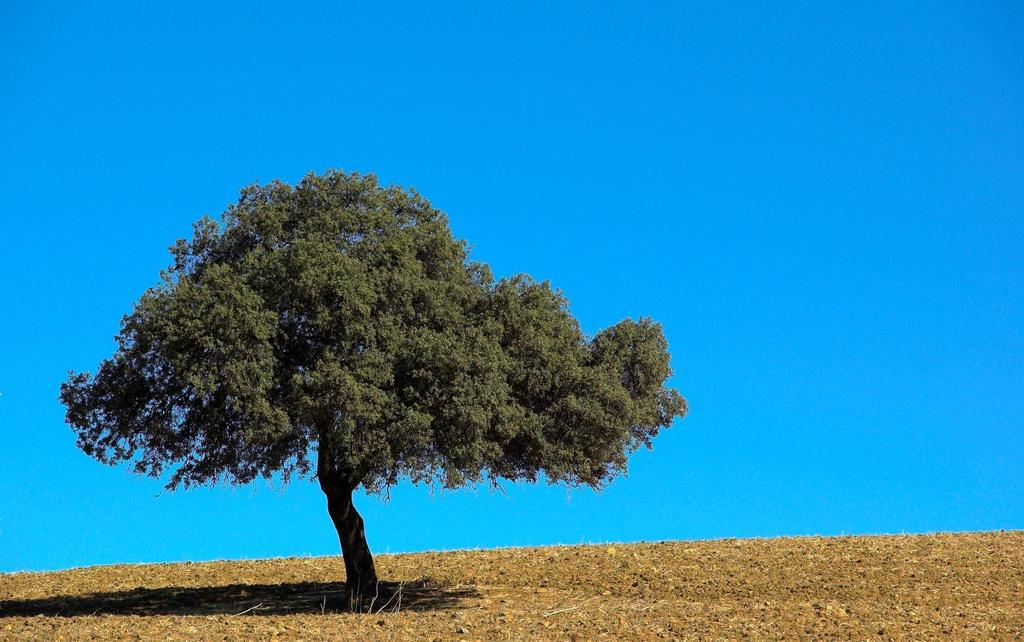What type of natural element can be seen in the image? There is a tree in the image. Where is the tree located? The tree is on dry land. What color is the sky in the image? The sky is blue in color. What type of meal is being prepared on the pan in the image? There is no pan or meal preparation present in the image; it only features a tree on dry land with a blue sky. 